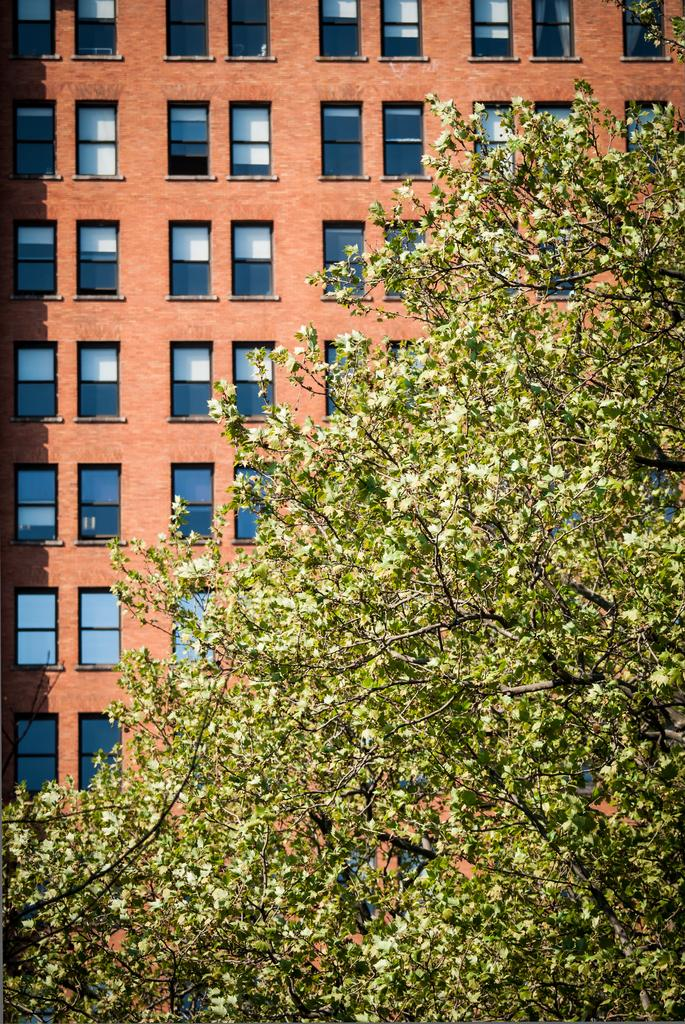What is the main subject in the foreground of the image? There is a tree in the foreground of the image. How close is the tree to the viewer in the image? The tree is in close view in the image. What type of building can be seen in the background of the image? There is a brown building with glass windows in the background of the image. Can you see any toes sticking out from under the tree in the image? There are no toes visible in the image; it features a tree in the foreground and a brown building with glass windows in the background. Is there a trampoline in the image? There is no trampoline present in the image. 